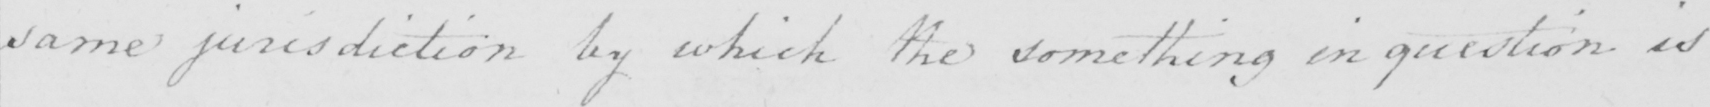What does this handwritten line say? same jurisdiction by which the something in question is 